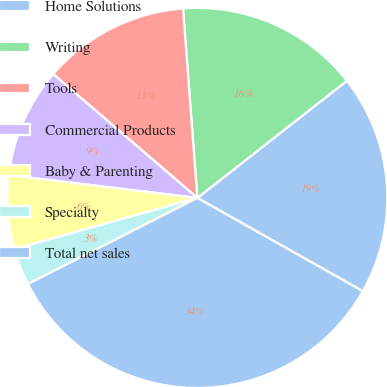Convert chart to OTSL. <chart><loc_0><loc_0><loc_500><loc_500><pie_chart><fcel>Home Solutions<fcel>Writing<fcel>Tools<fcel>Commercial Products<fcel>Baby & Parenting<fcel>Specialty<fcel>Total net sales<nl><fcel>18.74%<fcel>15.62%<fcel>12.5%<fcel>9.38%<fcel>6.26%<fcel>3.14%<fcel>34.34%<nl></chart> 